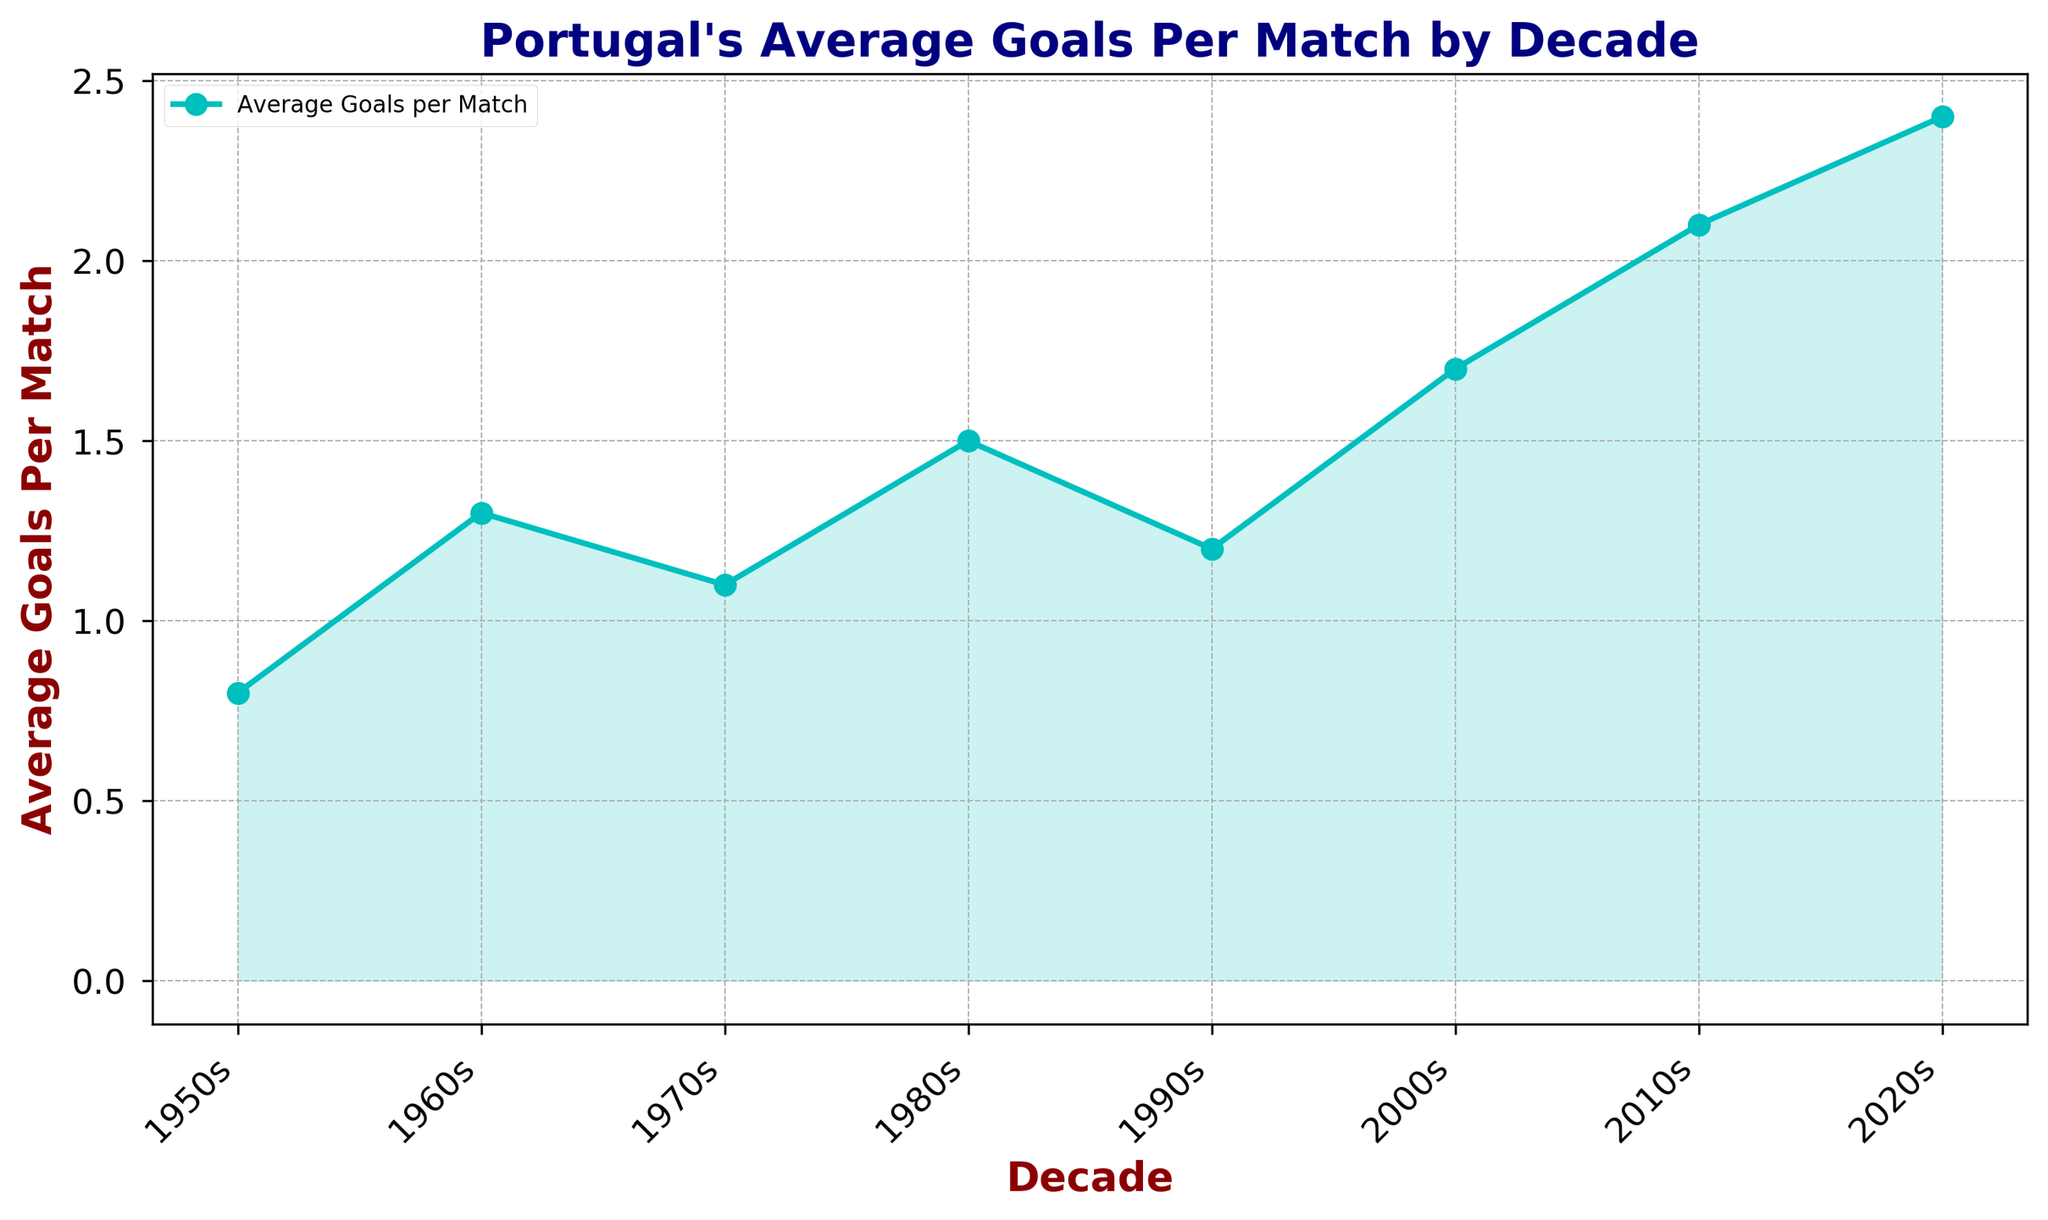What is the decade with the highest average goals per match? The decade with the highest average goals per match is identified by finding the peak value on the y-axis. From the graph, the highest average goals per match is 2.4, which occurs in the 2020s.
Answer: 2020s How many decades have an average goals per match greater than 1.5? To determine this, count the number of points on the graph where the average goals per match exceed 1.5. These decades are the 2000s, 2010s, and 2020s, making it three decades.
Answer: 3 Which decade showed the greatest improvement in average goals per match compared to the previous decade? The greatest improvement can be found by identifying the decade with the steepest rise between two consecutive decades. The most significant increase occurs from the 2010s (2.1) to the 2020s (2.4), which is an improvement of 0.3.
Answer: 2010s to 2020s What is the average of the average goals per match from the 1950s to the 1970s? Calculate the average by summing the average goals per match for the 1950s (0.8), 1960s (1.3), and 1970s (1.1), and then divide by 3. (0.8 + 1.3 + 1.1) / 3 = 1.0667.
Answer: 1.0667 Among the decades 1960s, 1980s, and 2000s, which one had the lowest average goals per match? Compare the average goals per match for each of these decades: 1960s (1.3), 1980s (1.5), and 2000s (1.7). The 1960s have the lowest value at 1.3.
Answer: 1960s In which decade did the average goals per match first exceed 1.0? By tracing the graph from left to right, the first value exceeding 1.0 occurs in the 1960s with a value of 1.3.
Answer: 1960s How much higher is the average goals per match in the 2020s compared to the 1950s? Subtract the average goals per match in the 1950s (0.8) from that in the 2020s (2.4), resulting in 2.4 - 0.8 = 1.6.
Answer: 1.6 Which has a greater difference: the increase from the 1980s to the 2000s or from the 2000s to the 2020s? Calculate the differences: from the 1980s (1.5) to the 2000s (1.7) is 0.2, and from the 2000s (1.7) to the 2020s (2.4) is 0.7. The greater difference is from the 2000s to the 2020s with 0.7.
Answer: 2000s to 2020s Estimate the area under the curve between the 1990s and the 2010s. Approximate the area by considering it as a trapezoid with the average goals per match values as the heights. (1.2 + 1.7 + 2.1) / 3 * (3 decades) = 1.6667 * 3 = 5.
Answer: 5 